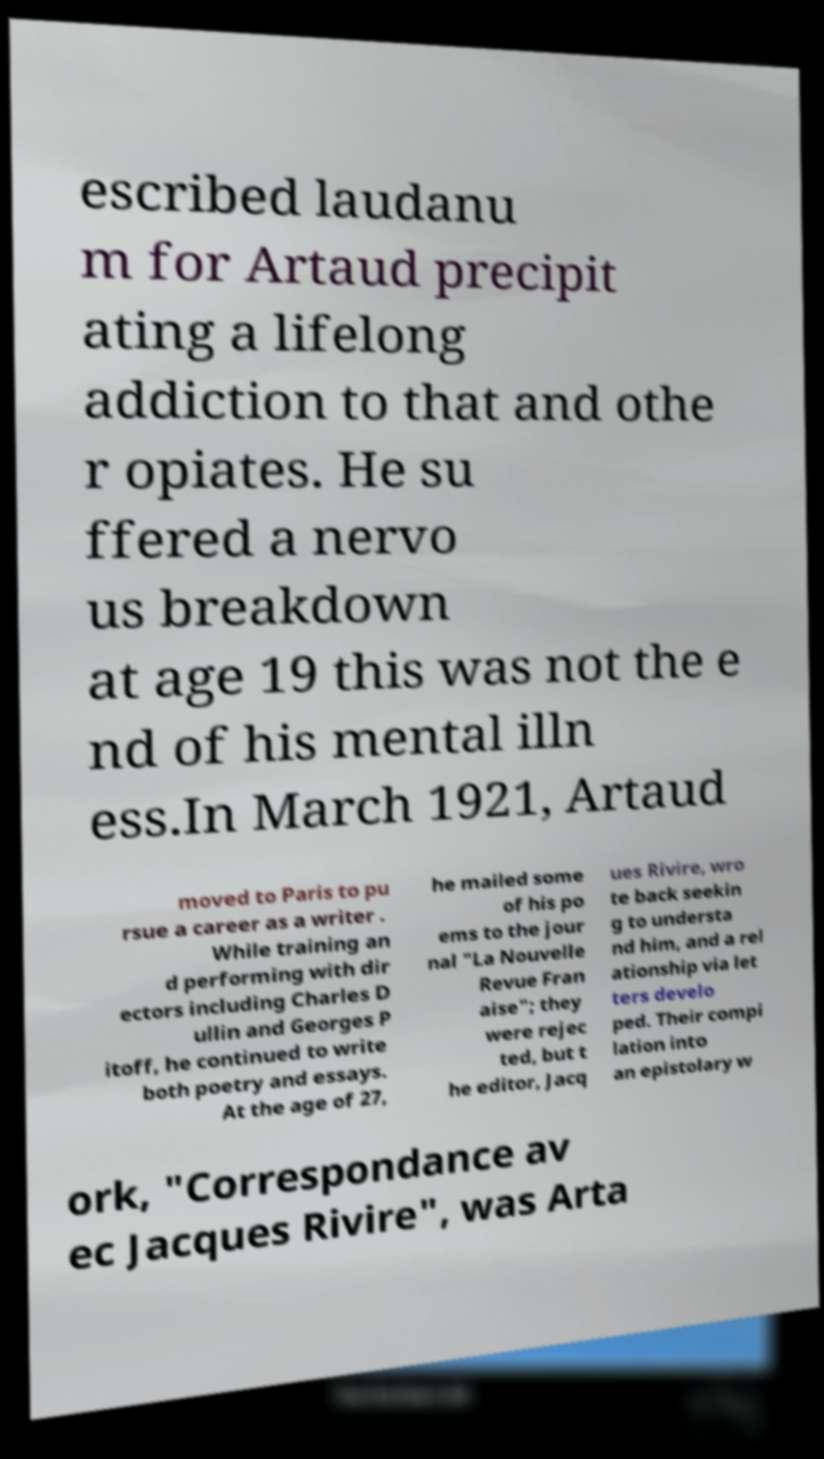What messages or text are displayed in this image? I need them in a readable, typed format. escribed laudanu m for Artaud precipit ating a lifelong addiction to that and othe r opiates. He su ffered a nervo us breakdown at age 19 this was not the e nd of his mental illn ess.In March 1921, Artaud moved to Paris to pu rsue a career as a writer . While training an d performing with dir ectors including Charles D ullin and Georges P itoff, he continued to write both poetry and essays. At the age of 27, he mailed some of his po ems to the jour nal "La Nouvelle Revue Fran aise"; they were rejec ted, but t he editor, Jacq ues Rivire, wro te back seekin g to understa nd him, and a rel ationship via let ters develo ped. Their compi lation into an epistolary w ork, "Correspondance av ec Jacques Rivire", was Arta 